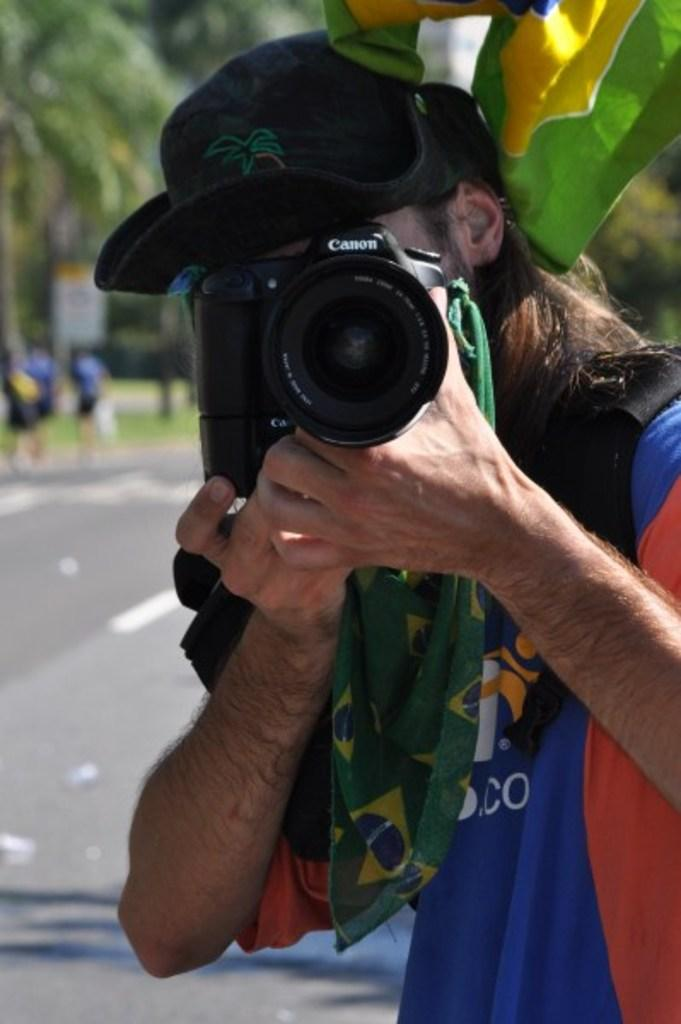What is the person in the image doing? The person is clicking pictures. What is the person holding in the image? The person has a camera in his hand. What can be seen in the top left corner of the image? There are trees in the top left corner of the image. What is happening on the left side of the image? There are persons walking on the left side of the image. What type of cracker is being used to take pictures in the image? There is no cracker present in the image; the person is using a camera to take pictures. 